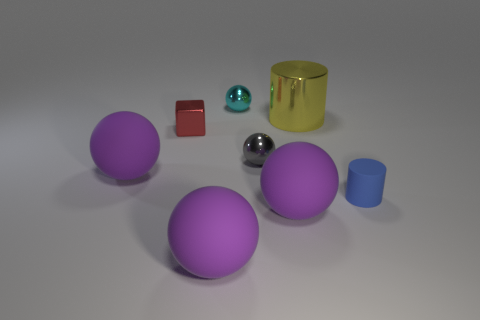Are there an equal number of big shiny cylinders that are left of the red metal block and small red shiny cubes that are in front of the gray thing?
Make the answer very short. Yes. What number of tiny red things have the same shape as the small gray thing?
Ensure brevity in your answer.  0. Is there a large purple sphere?
Give a very brief answer. Yes. Do the blue cylinder and the large ball to the right of the small cyan sphere have the same material?
Offer a very short reply. Yes. What is the material of the red thing that is the same size as the cyan shiny thing?
Ensure brevity in your answer.  Metal. Is there a small brown cylinder that has the same material as the cyan thing?
Your answer should be compact. No. There is a large object behind the purple object that is behind the small cylinder; are there any purple rubber balls right of it?
Provide a succinct answer. No. There is a red object that is the same size as the blue matte cylinder; what is its shape?
Offer a very short reply. Cube. Do the object that is behind the big yellow cylinder and the purple matte sphere to the right of the small gray thing have the same size?
Your response must be concise. No. What number of large green balls are there?
Ensure brevity in your answer.  0. 